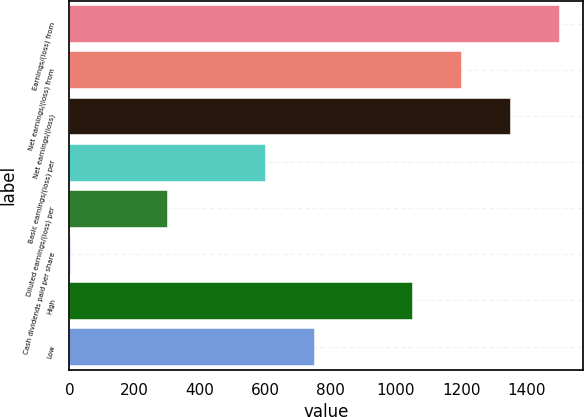Convert chart to OTSL. <chart><loc_0><loc_0><loc_500><loc_500><bar_chart><fcel>Earnings/(loss) from<fcel>Net earnings/(loss) from<fcel>Net earnings/(loss)<fcel>Basic earnings/(loss) per<fcel>Diluted earnings/(loss) per<fcel>Cash dividends paid per share<fcel>High<fcel>Low<nl><fcel>1499.02<fcel>1199.29<fcel>1349.15<fcel>599.82<fcel>300.09<fcel>0.35<fcel>1049.42<fcel>749.69<nl></chart> 